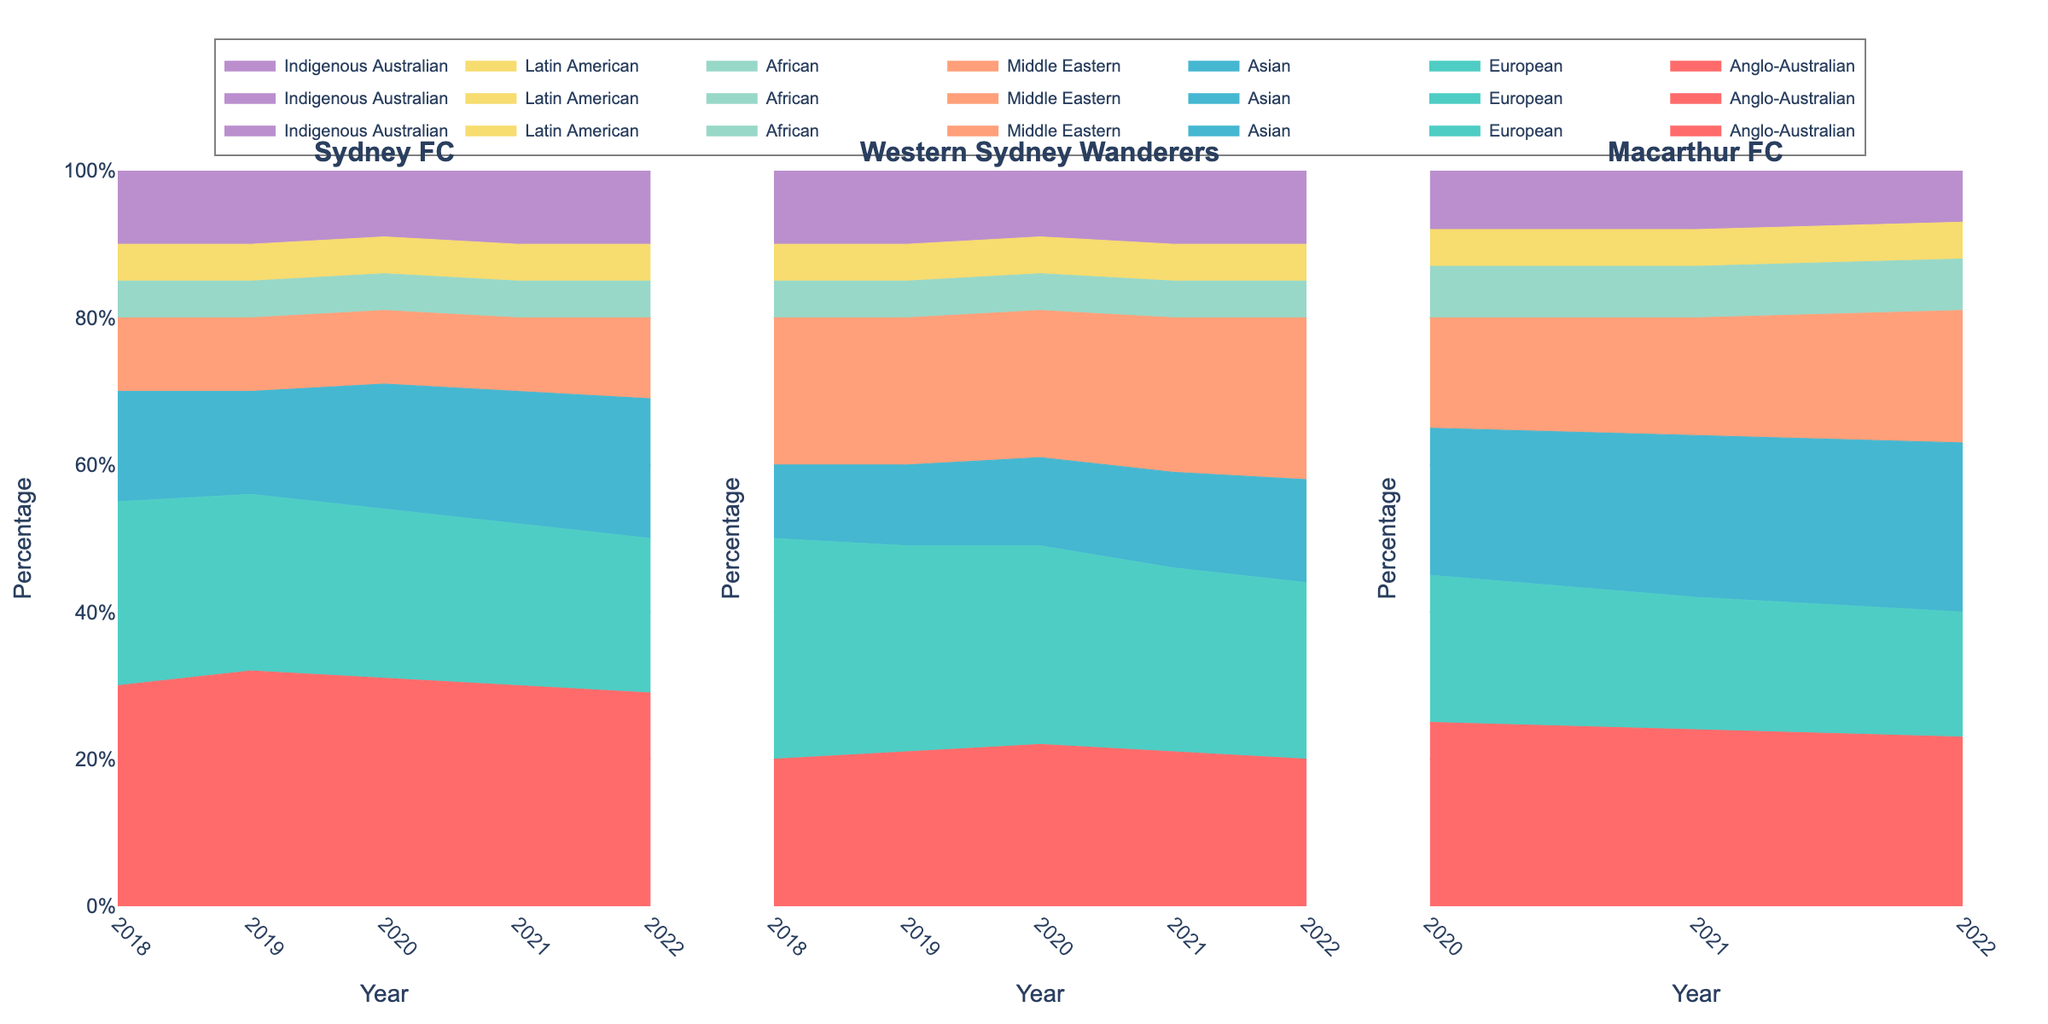What's the title of the chart? The title of the chart is displayed at the top of the figure, summarizing the data visualization.
Answer: Fanbase Composition of Different Football Clubs in Sydney by Ethnicity What is the range of years included in the data for Sydney FC? Look at the x-axis label for Sydney FC, which shows the range of years represented in the data.
Answer: 2018 to 2022 Which ethnicity has the smallest fanbase percentage in Western Sydney Wanderers throughout the years? By examining the stacked areas for Western Sydney Wanderers, assess which color strip appears to be consistently the smallest.
Answer: African How did the percentage of the Anglo-Australian fanbase in Sydney FC change from 2018 to 2022? Follow the section of the stacked area chart for Anglo-Australian ethnicity in Sydney FC from 2018 to 2022 to see the change.
Answer: It decreased from 30% to 29% In 2022, which club had the highest percentage of Asian fans? Compare the Asian sections (Review the color legend) of the stacked areas for all clubs in 2022 and determine the highest one.
Answer: Macarthur FC Which club showed an increase in the Middle Eastern fanbase from 2020 to 2022? Look at the Middle Eastern sections of each club's stacked area chart to identify which one shows a visible increase in percentage.
Answer: Macarthur FC Between 2018 and 2022, which club had the largest decrease in European fans? Compare the European sections of the stacked areas for each club between 2018 and 2022 to find the largest decrease.
Answer: Sydney FC Which ethnicity remained constant in percentage for Sydney FC from 2018 to 2022? Identify any ethnic section in the stacked area chart for Sydney FC that appears unchanged across the years.
Answer: Middle Eastern Which ethnicity was consistently higher in Macarthur FC compared to Western Sydney Wanderers for the years they overlap? Review the percentage sections of each ethnicity in Macarthur FC and Western Sydney Wanderers during the overlapping years (2020-2022).
Answer: Asian How did the Indigenous Australian fanbase percentage in Western Sydney Wanderers change from 2020 to 2022? Follow the Indigenous Australian sections of the stacked area chart for Western Sydney Wanderers from 2020 to 2022 to see the change.
Answer: It remained constant at 10% 